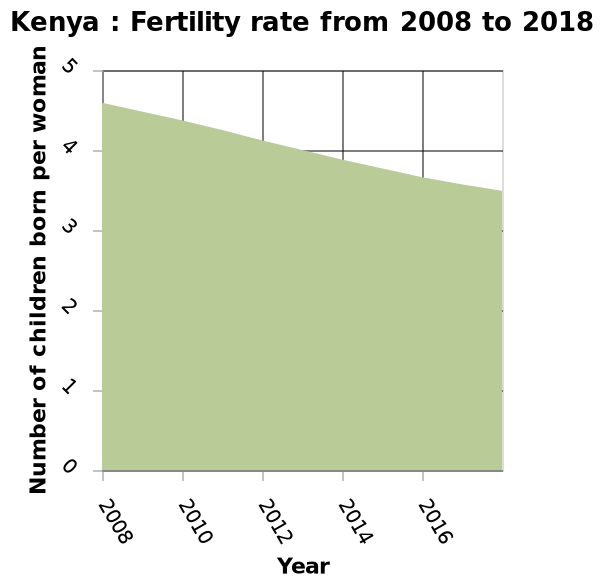<image>
How has the number of children born per woman changed over time?  The number of children born per woman has slowly decreased from over 4 to under 4. please describe the details of the chart Kenya : Fertility rate from 2008 to 2018 is a area graph. Year is measured on the x-axis. A linear scale of range 0 to 5 can be found along the y-axis, marked Number of children born per woman. What is the range of the y-axis scale on the graph? The range of the y-axis scale is from 0 to 5. Has the number of children born per woman increased or decreased over the years?  The number of children born per woman has decreased over the years. 